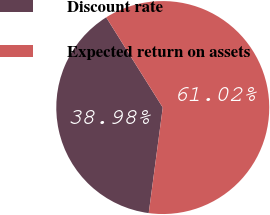<chart> <loc_0><loc_0><loc_500><loc_500><pie_chart><fcel>Discount rate<fcel>Expected return on assets<nl><fcel>38.98%<fcel>61.02%<nl></chart> 